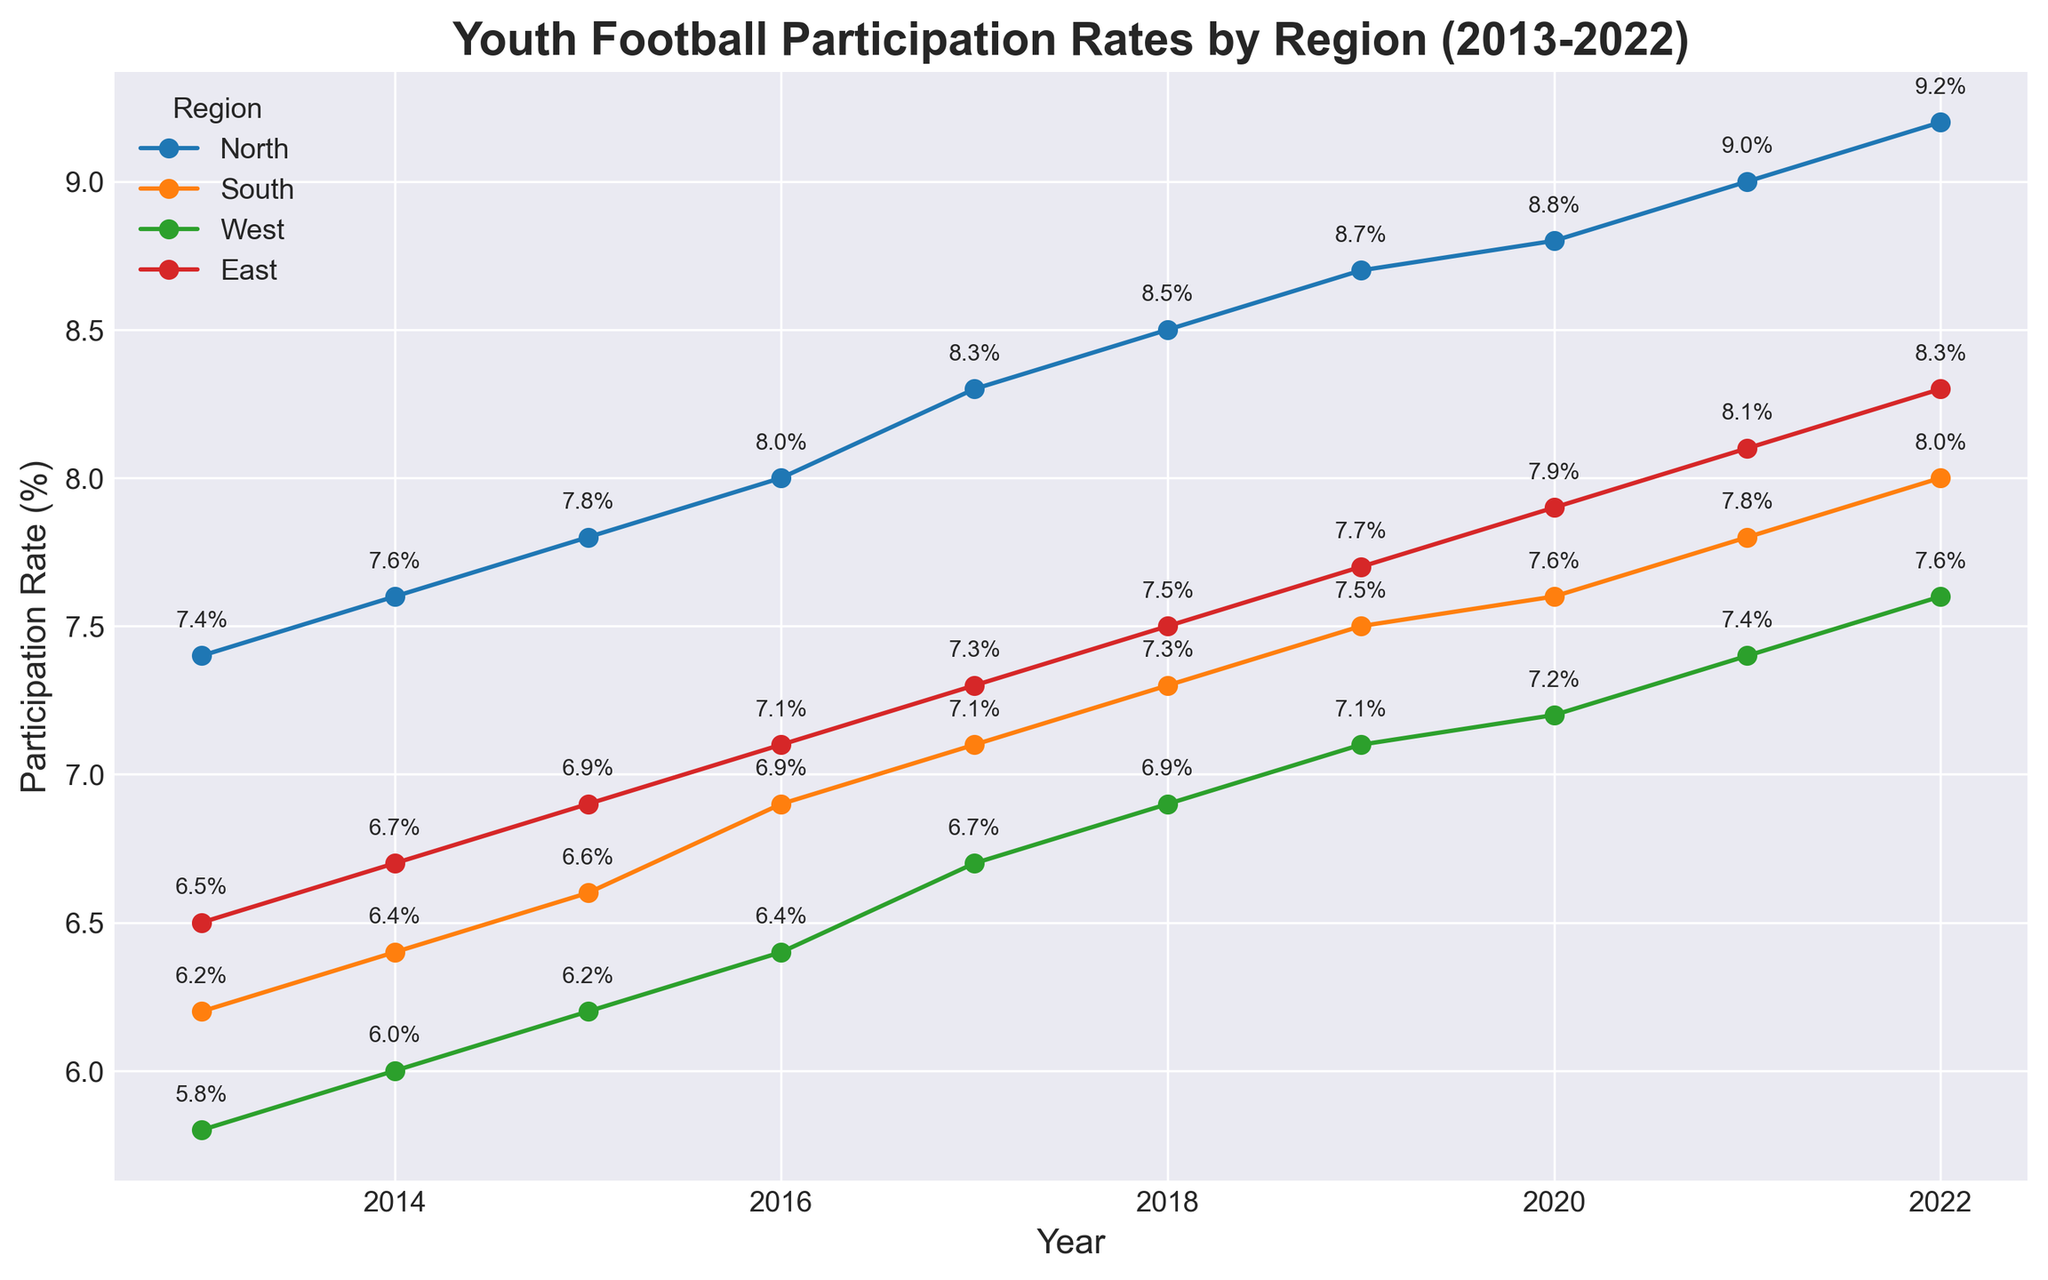What is the participation rate in the North region in 2022? Locate the data point for the North region in the year 2022. The annotation shows a participation rate of 9.2%.
Answer: 9.2% Which region had the highest participation rate in 2022? Compare the participation rates for all regions in 2022. The North region has the highest rate at 9.2%.
Answer: North What is the average participation rate in the East region from 2013 to 2022? Sum the participation rates for East from 2013 to 2022 and divide by the number of years. (6.5 + 6.7 + 6.9 + 7.1 + 7.3 + 7.5 + 7.7 + 7.9 + 8.1 + 8.3)/10 = 7.4%
Answer: 7.4% How much did the participation rate increase in the South region between 2017 and 2022? Subtract the participation rate in 2017 from that in 2022 for the South region. 8.0% - 7.1% = 0.9%
Answer: 0.9% Which region showed the least growth in participation rate from 2013 to 2022? Calculate the total increase for each region and identify the smallest value. The West region grew from 5.8% to 7.6%, which is an increase of 1.8%, the smallest among the regions.
Answer: West In which year did the West region's participation rate first surpass 7%? Look at the progression of participation rates in the West region. In 2019, the rate is 7.1%, the first year it surpasses 7%.
Answer: 2019 Among all regions, which one had the slowest average yearly growth rate over this period? Calculate the average yearly growth rate (total growth/number of years) for each region. The West region's growth is (7.6 - 5.8)/10 = 0.18% per year, the slowest growth rate.
Answer: West By how much did the North region's participation rate exceed the South region's rate in 2022? Subtract the South's rate from the North's rate for 2022. 9.2% - 8.0% = 1.2%
Answer: 1.2% How many regions had a participation rate above 8% in 2022? Check each region's participation rate in 2022 and count those above 8%. North, South, and East had rates above 8%.
Answer: 3 What's the difference between the highest and lowest participation rates in 2015 and which regions did they belong to? Identify the highest and lowest rates in 2015 and find the difference. The highest is North at 7.8%, and the lowest is West at 6.2%. 7.8% - 6.2% = 1.6%
Answer: 1.6% (North and West) 